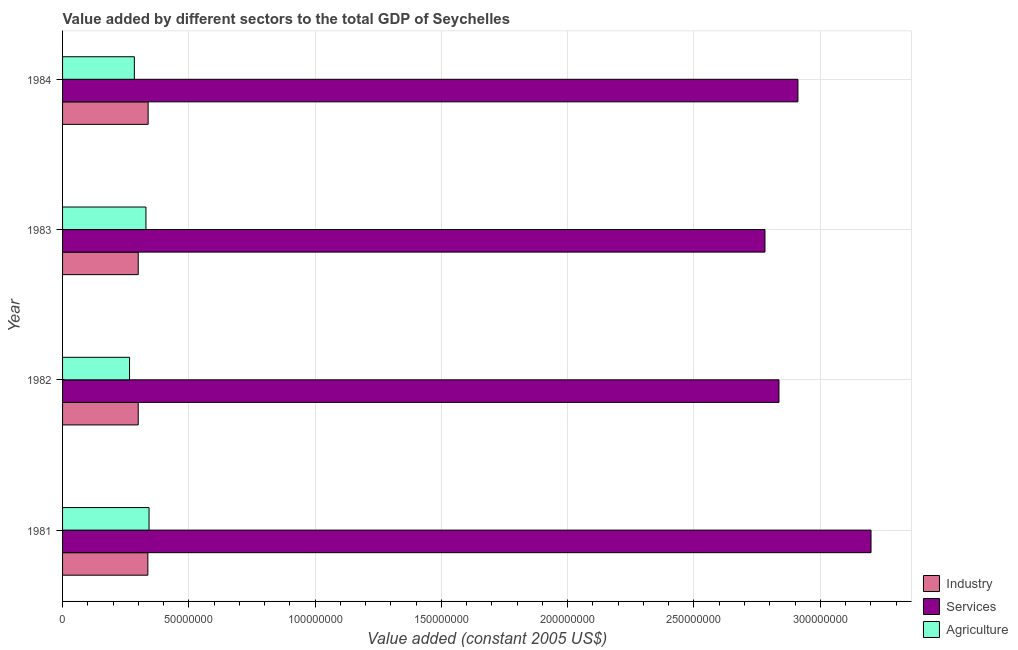How many groups of bars are there?
Your answer should be compact. 4. Are the number of bars on each tick of the Y-axis equal?
Offer a very short reply. Yes. How many bars are there on the 1st tick from the top?
Ensure brevity in your answer.  3. How many bars are there on the 2nd tick from the bottom?
Your answer should be compact. 3. What is the value added by industrial sector in 1983?
Your answer should be compact. 3.00e+07. Across all years, what is the maximum value added by services?
Your response must be concise. 3.20e+08. Across all years, what is the minimum value added by industrial sector?
Your answer should be compact. 3.00e+07. In which year was the value added by services maximum?
Provide a short and direct response. 1981. In which year was the value added by agricultural sector minimum?
Offer a very short reply. 1982. What is the total value added by agricultural sector in the graph?
Keep it short and to the point. 1.22e+08. What is the difference between the value added by agricultural sector in 1981 and that in 1984?
Provide a succinct answer. 5.82e+06. What is the difference between the value added by services in 1984 and the value added by industrial sector in 1981?
Offer a very short reply. 2.57e+08. What is the average value added by services per year?
Your answer should be compact. 2.93e+08. In the year 1983, what is the difference between the value added by services and value added by agricultural sector?
Offer a terse response. 2.45e+08. In how many years, is the value added by industrial sector greater than 130000000 US$?
Offer a terse response. 0. What is the ratio of the value added by agricultural sector in 1982 to that in 1984?
Make the answer very short. 0.93. Is the value added by services in 1981 less than that in 1982?
Make the answer very short. No. Is the difference between the value added by industrial sector in 1982 and 1984 greater than the difference between the value added by agricultural sector in 1982 and 1984?
Provide a short and direct response. No. What is the difference between the highest and the second highest value added by services?
Provide a short and direct response. 2.89e+07. What is the difference between the highest and the lowest value added by agricultural sector?
Offer a very short reply. 7.73e+06. What does the 1st bar from the top in 1984 represents?
Your answer should be very brief. Agriculture. What does the 1st bar from the bottom in 1982 represents?
Give a very brief answer. Industry. How many bars are there?
Give a very brief answer. 12. Are all the bars in the graph horizontal?
Give a very brief answer. Yes. How many years are there in the graph?
Your answer should be compact. 4. What is the difference between two consecutive major ticks on the X-axis?
Provide a succinct answer. 5.00e+07. Are the values on the major ticks of X-axis written in scientific E-notation?
Provide a succinct answer. No. What is the title of the graph?
Your response must be concise. Value added by different sectors to the total GDP of Seychelles. What is the label or title of the X-axis?
Keep it short and to the point. Value added (constant 2005 US$). What is the label or title of the Y-axis?
Provide a short and direct response. Year. What is the Value added (constant 2005 US$) in Industry in 1981?
Give a very brief answer. 3.38e+07. What is the Value added (constant 2005 US$) of Services in 1981?
Make the answer very short. 3.20e+08. What is the Value added (constant 2005 US$) in Agriculture in 1981?
Ensure brevity in your answer.  3.42e+07. What is the Value added (constant 2005 US$) of Industry in 1982?
Give a very brief answer. 3.00e+07. What is the Value added (constant 2005 US$) in Services in 1982?
Your answer should be very brief. 2.84e+08. What is the Value added (constant 2005 US$) in Agriculture in 1982?
Ensure brevity in your answer.  2.65e+07. What is the Value added (constant 2005 US$) of Industry in 1983?
Make the answer very short. 3.00e+07. What is the Value added (constant 2005 US$) of Services in 1983?
Make the answer very short. 2.78e+08. What is the Value added (constant 2005 US$) of Agriculture in 1983?
Offer a terse response. 3.30e+07. What is the Value added (constant 2005 US$) of Industry in 1984?
Give a very brief answer. 3.39e+07. What is the Value added (constant 2005 US$) in Services in 1984?
Offer a terse response. 2.91e+08. What is the Value added (constant 2005 US$) in Agriculture in 1984?
Make the answer very short. 2.84e+07. Across all years, what is the maximum Value added (constant 2005 US$) in Industry?
Provide a short and direct response. 3.39e+07. Across all years, what is the maximum Value added (constant 2005 US$) of Services?
Ensure brevity in your answer.  3.20e+08. Across all years, what is the maximum Value added (constant 2005 US$) in Agriculture?
Your answer should be compact. 3.42e+07. Across all years, what is the minimum Value added (constant 2005 US$) in Industry?
Offer a terse response. 3.00e+07. Across all years, what is the minimum Value added (constant 2005 US$) of Services?
Offer a very short reply. 2.78e+08. Across all years, what is the minimum Value added (constant 2005 US$) in Agriculture?
Ensure brevity in your answer.  2.65e+07. What is the total Value added (constant 2005 US$) of Industry in the graph?
Offer a terse response. 1.28e+08. What is the total Value added (constant 2005 US$) of Services in the graph?
Offer a very short reply. 1.17e+09. What is the total Value added (constant 2005 US$) of Agriculture in the graph?
Your answer should be compact. 1.22e+08. What is the difference between the Value added (constant 2005 US$) in Industry in 1981 and that in 1982?
Make the answer very short. 3.82e+06. What is the difference between the Value added (constant 2005 US$) in Services in 1981 and that in 1982?
Your answer should be compact. 3.64e+07. What is the difference between the Value added (constant 2005 US$) of Agriculture in 1981 and that in 1982?
Give a very brief answer. 7.73e+06. What is the difference between the Value added (constant 2005 US$) in Industry in 1981 and that in 1983?
Ensure brevity in your answer.  3.82e+06. What is the difference between the Value added (constant 2005 US$) of Services in 1981 and that in 1983?
Offer a very short reply. 4.20e+07. What is the difference between the Value added (constant 2005 US$) in Agriculture in 1981 and that in 1983?
Keep it short and to the point. 1.23e+06. What is the difference between the Value added (constant 2005 US$) in Industry in 1981 and that in 1984?
Your response must be concise. -1.06e+05. What is the difference between the Value added (constant 2005 US$) of Services in 1981 and that in 1984?
Your response must be concise. 2.89e+07. What is the difference between the Value added (constant 2005 US$) of Agriculture in 1981 and that in 1984?
Provide a short and direct response. 5.82e+06. What is the difference between the Value added (constant 2005 US$) in Industry in 1982 and that in 1983?
Your response must be concise. 0. What is the difference between the Value added (constant 2005 US$) of Services in 1982 and that in 1983?
Make the answer very short. 5.54e+06. What is the difference between the Value added (constant 2005 US$) in Agriculture in 1982 and that in 1983?
Ensure brevity in your answer.  -6.50e+06. What is the difference between the Value added (constant 2005 US$) of Industry in 1982 and that in 1984?
Ensure brevity in your answer.  -3.92e+06. What is the difference between the Value added (constant 2005 US$) of Services in 1982 and that in 1984?
Provide a short and direct response. -7.51e+06. What is the difference between the Value added (constant 2005 US$) in Agriculture in 1982 and that in 1984?
Provide a short and direct response. -1.90e+06. What is the difference between the Value added (constant 2005 US$) of Industry in 1983 and that in 1984?
Offer a terse response. -3.92e+06. What is the difference between the Value added (constant 2005 US$) in Services in 1983 and that in 1984?
Your response must be concise. -1.30e+07. What is the difference between the Value added (constant 2005 US$) of Agriculture in 1983 and that in 1984?
Offer a very short reply. 4.60e+06. What is the difference between the Value added (constant 2005 US$) in Industry in 1981 and the Value added (constant 2005 US$) in Services in 1982?
Offer a terse response. -2.50e+08. What is the difference between the Value added (constant 2005 US$) in Industry in 1981 and the Value added (constant 2005 US$) in Agriculture in 1982?
Your answer should be compact. 7.26e+06. What is the difference between the Value added (constant 2005 US$) in Services in 1981 and the Value added (constant 2005 US$) in Agriculture in 1982?
Offer a terse response. 2.94e+08. What is the difference between the Value added (constant 2005 US$) of Industry in 1981 and the Value added (constant 2005 US$) of Services in 1983?
Provide a succinct answer. -2.44e+08. What is the difference between the Value added (constant 2005 US$) of Industry in 1981 and the Value added (constant 2005 US$) of Agriculture in 1983?
Keep it short and to the point. 7.57e+05. What is the difference between the Value added (constant 2005 US$) in Services in 1981 and the Value added (constant 2005 US$) in Agriculture in 1983?
Provide a succinct answer. 2.87e+08. What is the difference between the Value added (constant 2005 US$) in Industry in 1981 and the Value added (constant 2005 US$) in Services in 1984?
Make the answer very short. -2.57e+08. What is the difference between the Value added (constant 2005 US$) in Industry in 1981 and the Value added (constant 2005 US$) in Agriculture in 1984?
Your response must be concise. 5.35e+06. What is the difference between the Value added (constant 2005 US$) of Services in 1981 and the Value added (constant 2005 US$) of Agriculture in 1984?
Your answer should be compact. 2.92e+08. What is the difference between the Value added (constant 2005 US$) of Industry in 1982 and the Value added (constant 2005 US$) of Services in 1983?
Give a very brief answer. -2.48e+08. What is the difference between the Value added (constant 2005 US$) in Industry in 1982 and the Value added (constant 2005 US$) in Agriculture in 1983?
Your response must be concise. -3.06e+06. What is the difference between the Value added (constant 2005 US$) of Services in 1982 and the Value added (constant 2005 US$) of Agriculture in 1983?
Offer a very short reply. 2.51e+08. What is the difference between the Value added (constant 2005 US$) of Industry in 1982 and the Value added (constant 2005 US$) of Services in 1984?
Provide a short and direct response. -2.61e+08. What is the difference between the Value added (constant 2005 US$) of Industry in 1982 and the Value added (constant 2005 US$) of Agriculture in 1984?
Make the answer very short. 1.54e+06. What is the difference between the Value added (constant 2005 US$) of Services in 1982 and the Value added (constant 2005 US$) of Agriculture in 1984?
Your response must be concise. 2.55e+08. What is the difference between the Value added (constant 2005 US$) of Industry in 1983 and the Value added (constant 2005 US$) of Services in 1984?
Make the answer very short. -2.61e+08. What is the difference between the Value added (constant 2005 US$) of Industry in 1983 and the Value added (constant 2005 US$) of Agriculture in 1984?
Keep it short and to the point. 1.54e+06. What is the difference between the Value added (constant 2005 US$) in Services in 1983 and the Value added (constant 2005 US$) in Agriculture in 1984?
Keep it short and to the point. 2.50e+08. What is the average Value added (constant 2005 US$) of Industry per year?
Provide a short and direct response. 3.19e+07. What is the average Value added (constant 2005 US$) in Services per year?
Provide a succinct answer. 2.93e+08. What is the average Value added (constant 2005 US$) of Agriculture per year?
Provide a succinct answer. 3.06e+07. In the year 1981, what is the difference between the Value added (constant 2005 US$) in Industry and Value added (constant 2005 US$) in Services?
Provide a succinct answer. -2.86e+08. In the year 1981, what is the difference between the Value added (constant 2005 US$) of Industry and Value added (constant 2005 US$) of Agriculture?
Your answer should be very brief. -4.70e+05. In the year 1981, what is the difference between the Value added (constant 2005 US$) of Services and Value added (constant 2005 US$) of Agriculture?
Make the answer very short. 2.86e+08. In the year 1982, what is the difference between the Value added (constant 2005 US$) of Industry and Value added (constant 2005 US$) of Services?
Offer a very short reply. -2.54e+08. In the year 1982, what is the difference between the Value added (constant 2005 US$) in Industry and Value added (constant 2005 US$) in Agriculture?
Your answer should be compact. 3.44e+06. In the year 1982, what is the difference between the Value added (constant 2005 US$) in Services and Value added (constant 2005 US$) in Agriculture?
Provide a short and direct response. 2.57e+08. In the year 1983, what is the difference between the Value added (constant 2005 US$) in Industry and Value added (constant 2005 US$) in Services?
Your answer should be compact. -2.48e+08. In the year 1983, what is the difference between the Value added (constant 2005 US$) of Industry and Value added (constant 2005 US$) of Agriculture?
Offer a very short reply. -3.06e+06. In the year 1983, what is the difference between the Value added (constant 2005 US$) in Services and Value added (constant 2005 US$) in Agriculture?
Offer a very short reply. 2.45e+08. In the year 1984, what is the difference between the Value added (constant 2005 US$) of Industry and Value added (constant 2005 US$) of Services?
Provide a succinct answer. -2.57e+08. In the year 1984, what is the difference between the Value added (constant 2005 US$) of Industry and Value added (constant 2005 US$) of Agriculture?
Ensure brevity in your answer.  5.46e+06. In the year 1984, what is the difference between the Value added (constant 2005 US$) of Services and Value added (constant 2005 US$) of Agriculture?
Keep it short and to the point. 2.63e+08. What is the ratio of the Value added (constant 2005 US$) of Industry in 1981 to that in 1982?
Offer a terse response. 1.13. What is the ratio of the Value added (constant 2005 US$) in Services in 1981 to that in 1982?
Offer a very short reply. 1.13. What is the ratio of the Value added (constant 2005 US$) of Agriculture in 1981 to that in 1982?
Keep it short and to the point. 1.29. What is the ratio of the Value added (constant 2005 US$) in Industry in 1981 to that in 1983?
Offer a terse response. 1.13. What is the ratio of the Value added (constant 2005 US$) in Services in 1981 to that in 1983?
Make the answer very short. 1.15. What is the ratio of the Value added (constant 2005 US$) in Agriculture in 1981 to that in 1983?
Your answer should be compact. 1.04. What is the ratio of the Value added (constant 2005 US$) of Industry in 1981 to that in 1984?
Give a very brief answer. 1. What is the ratio of the Value added (constant 2005 US$) in Services in 1981 to that in 1984?
Your response must be concise. 1.1. What is the ratio of the Value added (constant 2005 US$) of Agriculture in 1981 to that in 1984?
Your answer should be very brief. 1.2. What is the ratio of the Value added (constant 2005 US$) of Services in 1982 to that in 1983?
Your response must be concise. 1.02. What is the ratio of the Value added (constant 2005 US$) of Agriculture in 1982 to that in 1983?
Keep it short and to the point. 0.8. What is the ratio of the Value added (constant 2005 US$) of Industry in 1982 to that in 1984?
Make the answer very short. 0.88. What is the ratio of the Value added (constant 2005 US$) in Services in 1982 to that in 1984?
Ensure brevity in your answer.  0.97. What is the ratio of the Value added (constant 2005 US$) in Agriculture in 1982 to that in 1984?
Keep it short and to the point. 0.93. What is the ratio of the Value added (constant 2005 US$) of Industry in 1983 to that in 1984?
Offer a very short reply. 0.88. What is the ratio of the Value added (constant 2005 US$) in Services in 1983 to that in 1984?
Your answer should be compact. 0.96. What is the ratio of the Value added (constant 2005 US$) in Agriculture in 1983 to that in 1984?
Your answer should be compact. 1.16. What is the difference between the highest and the second highest Value added (constant 2005 US$) in Industry?
Keep it short and to the point. 1.06e+05. What is the difference between the highest and the second highest Value added (constant 2005 US$) of Services?
Ensure brevity in your answer.  2.89e+07. What is the difference between the highest and the second highest Value added (constant 2005 US$) in Agriculture?
Offer a very short reply. 1.23e+06. What is the difference between the highest and the lowest Value added (constant 2005 US$) of Industry?
Make the answer very short. 3.92e+06. What is the difference between the highest and the lowest Value added (constant 2005 US$) of Services?
Ensure brevity in your answer.  4.20e+07. What is the difference between the highest and the lowest Value added (constant 2005 US$) in Agriculture?
Offer a very short reply. 7.73e+06. 